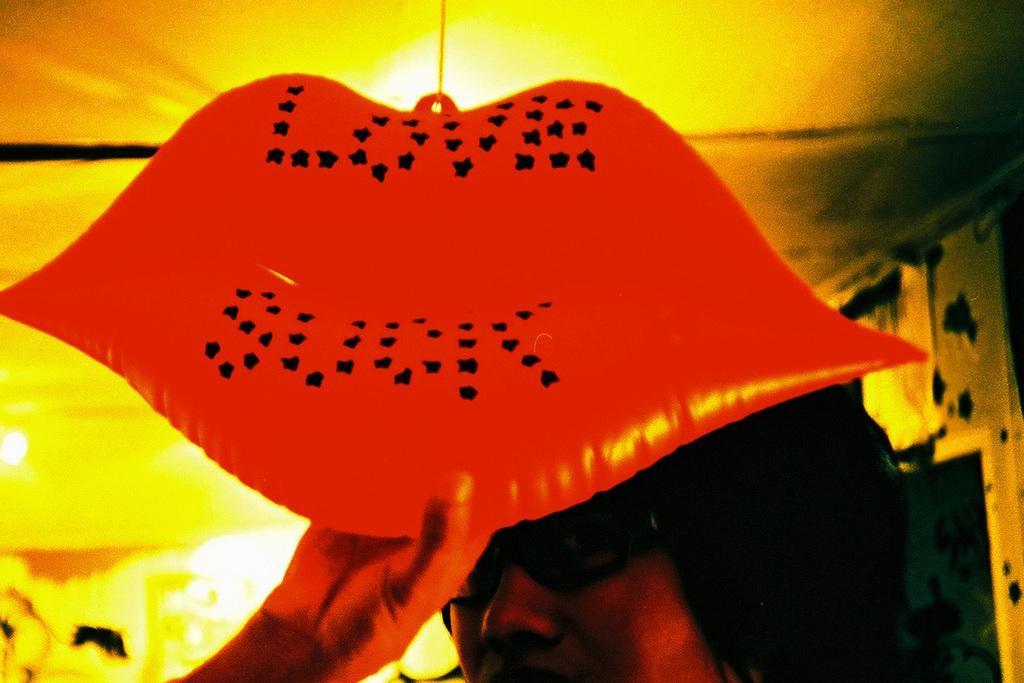How would you summarize this image in a sentence or two? In this picture we can see a woman wore a spectacle and holding an object with her hand and in the background we can see lights and it is blur. 